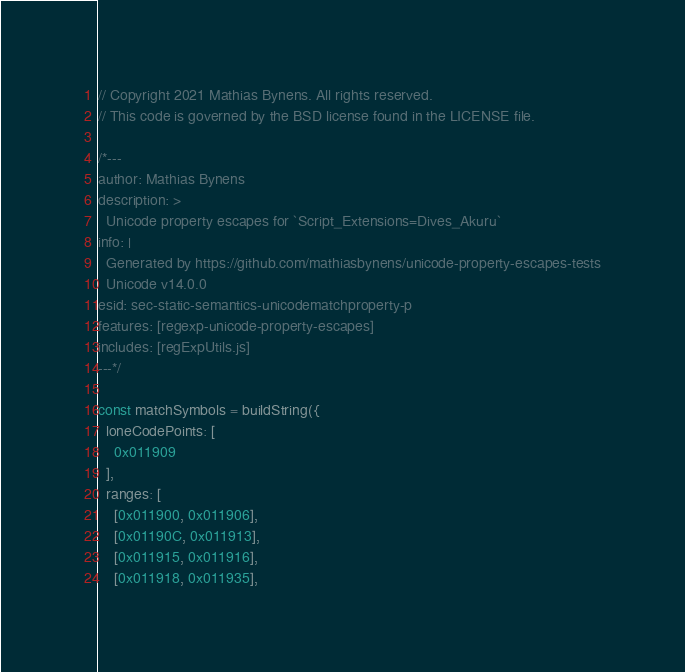Convert code to text. <code><loc_0><loc_0><loc_500><loc_500><_JavaScript_>// Copyright 2021 Mathias Bynens. All rights reserved.
// This code is governed by the BSD license found in the LICENSE file.

/*---
author: Mathias Bynens
description: >
  Unicode property escapes for `Script_Extensions=Dives_Akuru`
info: |
  Generated by https://github.com/mathiasbynens/unicode-property-escapes-tests
  Unicode v14.0.0
esid: sec-static-semantics-unicodematchproperty-p
features: [regexp-unicode-property-escapes]
includes: [regExpUtils.js]
---*/

const matchSymbols = buildString({
  loneCodePoints: [
    0x011909
  ],
  ranges: [
    [0x011900, 0x011906],
    [0x01190C, 0x011913],
    [0x011915, 0x011916],
    [0x011918, 0x011935],</code> 